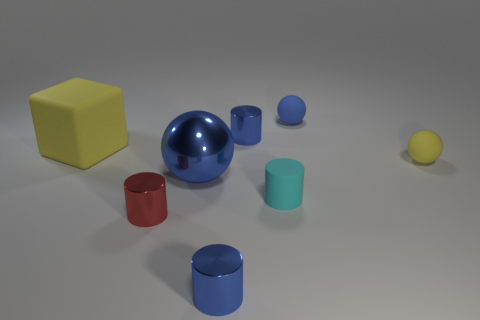What size is the rubber thing that is the same color as the metallic ball?
Provide a short and direct response. Small. Are there any red cylinders that have the same size as the shiny sphere?
Your answer should be very brief. No. There is another matte thing that is the same shape as the red thing; what color is it?
Keep it short and to the point. Cyan. There is a tiny blue shiny thing that is in front of the large blue metallic sphere; is there a red thing that is to the right of it?
Give a very brief answer. No. Does the red object to the left of the large metallic thing have the same shape as the large matte object?
Provide a short and direct response. No. What is the shape of the tiny yellow object?
Your response must be concise. Sphere. What number of small red cylinders are made of the same material as the small yellow ball?
Provide a succinct answer. 0. Do the big matte thing and the small sphere behind the tiny yellow object have the same color?
Ensure brevity in your answer.  No. What number of blue metal things are there?
Offer a very short reply. 3. Is there a large cube that has the same color as the big rubber object?
Your answer should be very brief. No. 